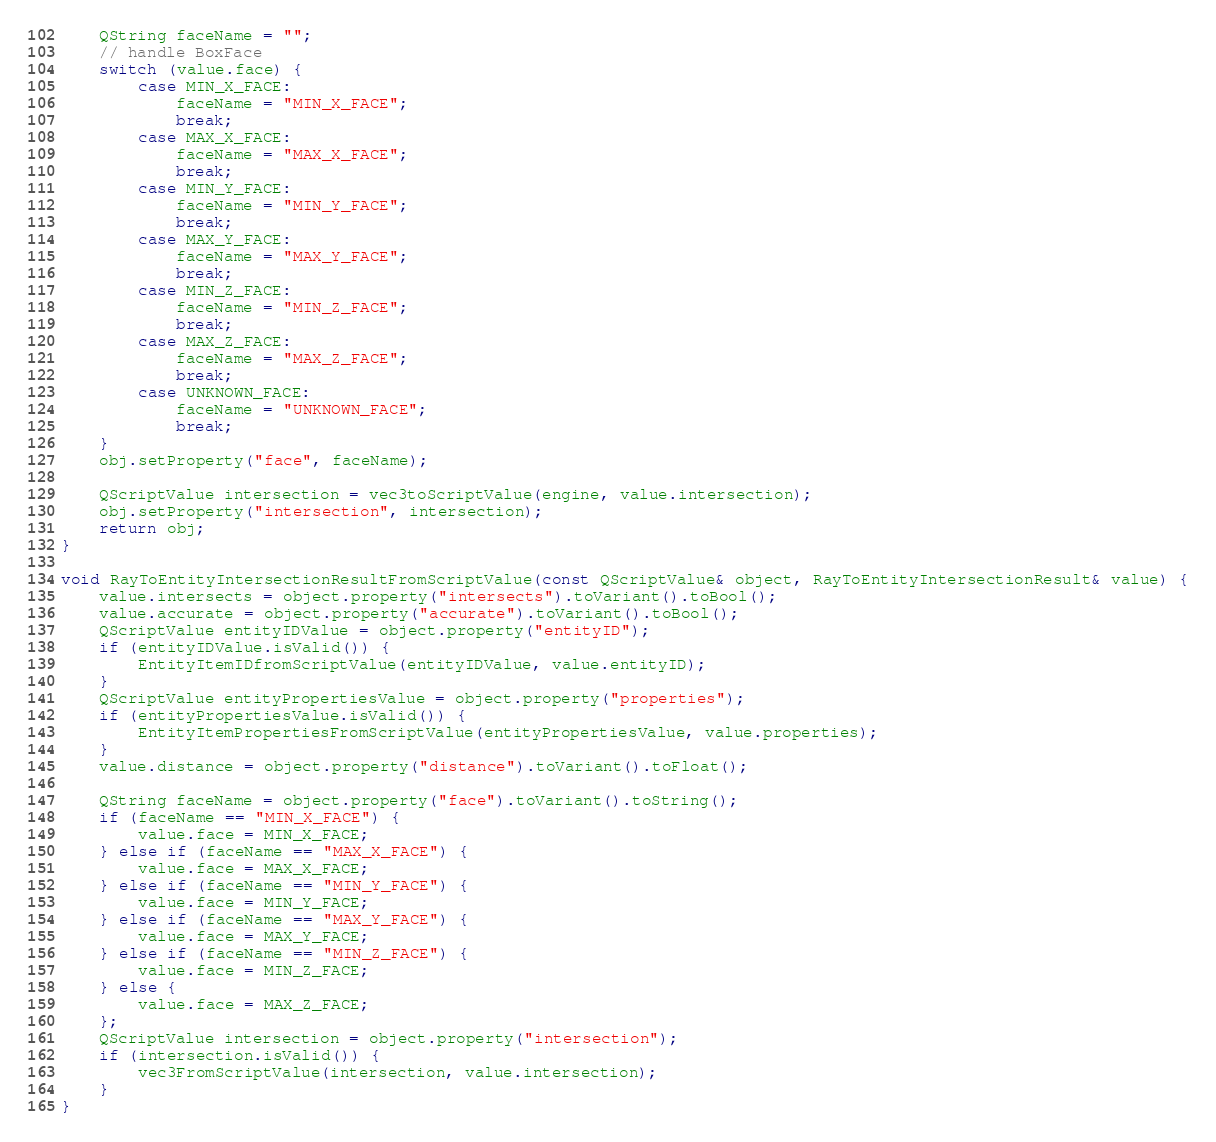<code> <loc_0><loc_0><loc_500><loc_500><_C++_>
    QString faceName = "";    
    // handle BoxFace
    switch (value.face) {
        case MIN_X_FACE:
            faceName = "MIN_X_FACE";
            break;
        case MAX_X_FACE:
            faceName = "MAX_X_FACE";
            break;
        case MIN_Y_FACE:
            faceName = "MIN_Y_FACE";
            break;
        case MAX_Y_FACE:
            faceName = "MAX_Y_FACE";
            break;
        case MIN_Z_FACE:
            faceName = "MIN_Z_FACE";
            break;
        case MAX_Z_FACE:
            faceName = "MAX_Z_FACE";
            break;
        case UNKNOWN_FACE:
            faceName = "UNKNOWN_FACE";
            break;
    }
    obj.setProperty("face", faceName);

    QScriptValue intersection = vec3toScriptValue(engine, value.intersection);
    obj.setProperty("intersection", intersection);
    return obj;
}

void RayToEntityIntersectionResultFromScriptValue(const QScriptValue& object, RayToEntityIntersectionResult& value) {
    value.intersects = object.property("intersects").toVariant().toBool();
    value.accurate = object.property("accurate").toVariant().toBool();
    QScriptValue entityIDValue = object.property("entityID");
    if (entityIDValue.isValid()) {
        EntityItemIDfromScriptValue(entityIDValue, value.entityID);
    }
    QScriptValue entityPropertiesValue = object.property("properties");
    if (entityPropertiesValue.isValid()) {
        EntityItemPropertiesFromScriptValue(entityPropertiesValue, value.properties);
    }
    value.distance = object.property("distance").toVariant().toFloat();

    QString faceName = object.property("face").toVariant().toString();
    if (faceName == "MIN_X_FACE") {
        value.face = MIN_X_FACE;
    } else if (faceName == "MAX_X_FACE") {
        value.face = MAX_X_FACE;
    } else if (faceName == "MIN_Y_FACE") {
        value.face = MIN_Y_FACE;
    } else if (faceName == "MAX_Y_FACE") {
        value.face = MAX_Y_FACE;
    } else if (faceName == "MIN_Z_FACE") {
        value.face = MIN_Z_FACE;
    } else {
        value.face = MAX_Z_FACE;
    };
    QScriptValue intersection = object.property("intersection");
    if (intersection.isValid()) {
        vec3FromScriptValue(intersection, value.intersection);
    }
}
</code> 